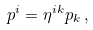<formula> <loc_0><loc_0><loc_500><loc_500>p ^ { i } = \eta ^ { i k } p _ { k } \, ,</formula> 